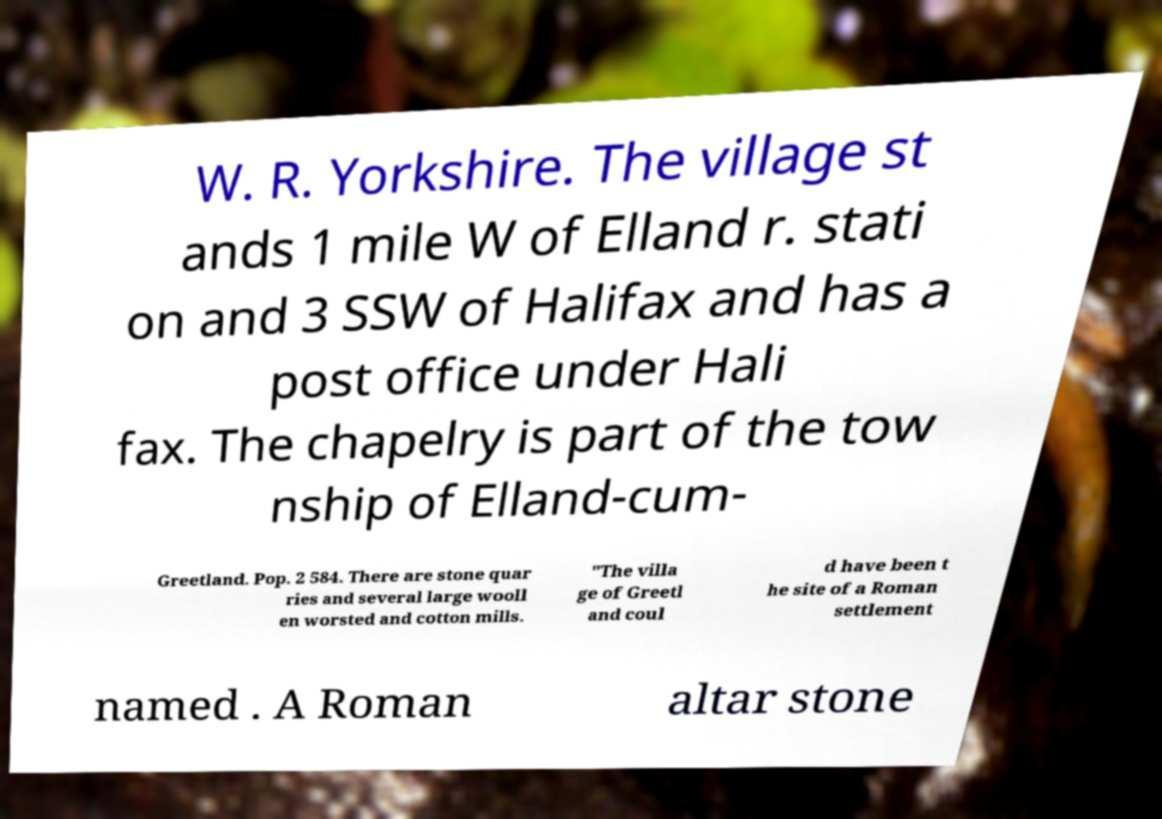Please identify and transcribe the text found in this image. W. R. Yorkshire. The village st ands 1 mile W of Elland r. stati on and 3 SSW of Halifax and has a post office under Hali fax. The chapelry is part of the tow nship of Elland-cum- Greetland. Pop. 2 584. There are stone quar ries and several large wooll en worsted and cotton mills. "The villa ge of Greetl and coul d have been t he site of a Roman settlement named . A Roman altar stone 